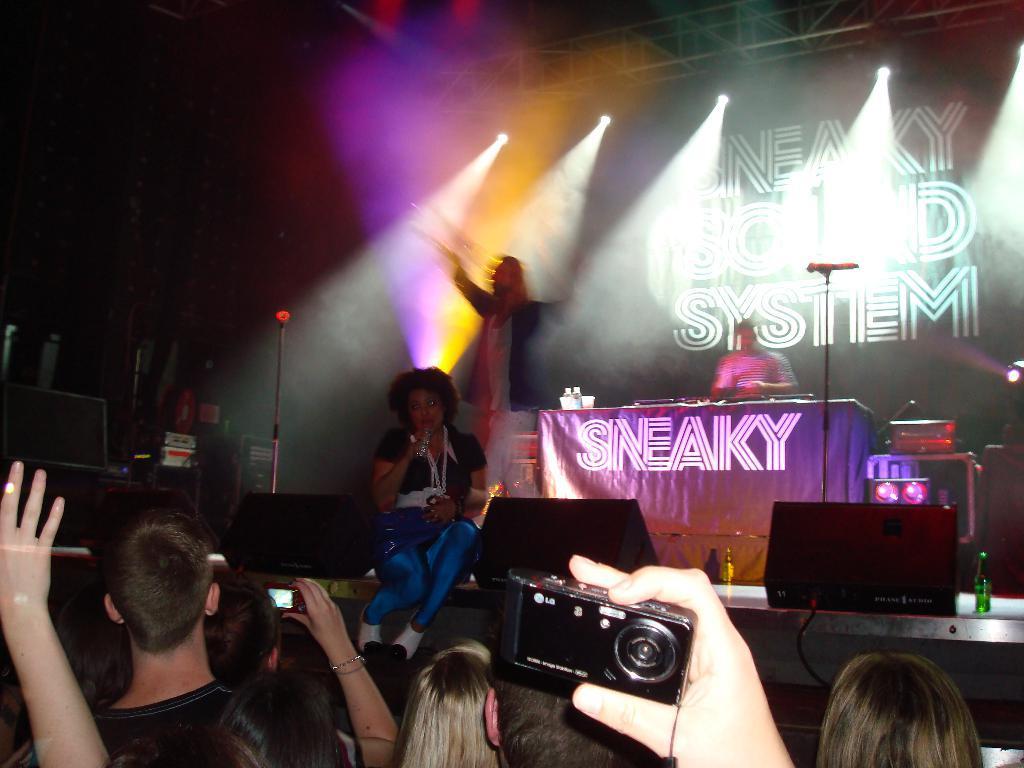Can you describe this image briefly? The image is taken in a live concert. There is a crowd which are listening to the music. In the center of the stage there is a lady sitting and singing a song behind her there is a man who is performing. In the background there is a board. 